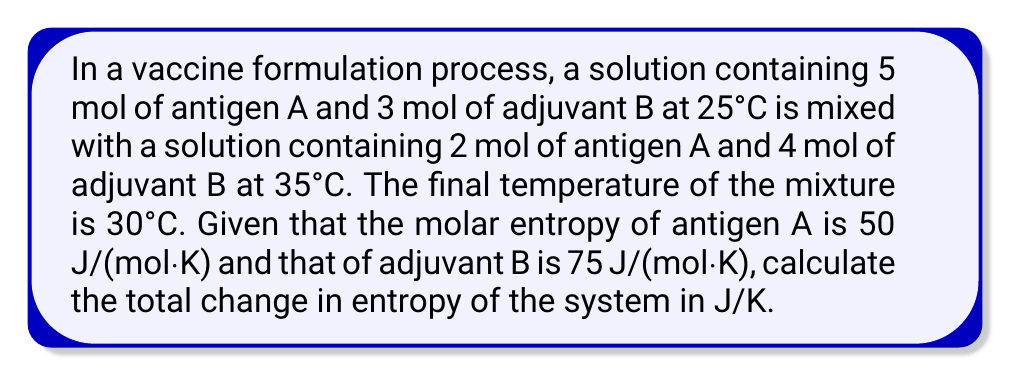Teach me how to tackle this problem. To solve this problem, we need to calculate the entropy change due to mixing and the entropy change due to temperature change.

Step 1: Calculate the initial entropy of each solution
Solution 1 (25°C):
$S_1 = 5 \cdot 50 + 3 \cdot 75 = 475$ J/K

Solution 2 (35°C):
$S_2 = 2 \cdot 50 + 4 \cdot 75 = 400$ J/K

Step 2: Calculate the final entropy of the mixture at 30°C
Total moles of A: $5 + 2 = 7$ mol
Total moles of B: $3 + 4 = 7$ mol
$S_f = 7 \cdot 50 + 7 \cdot 75 = 875$ J/K

Step 3: Calculate the entropy change due to mixing
$\Delta S_{mix} = S_f - (S_1 + S_2) = 875 - (475 + 400) = 0$ J/K

Step 4: Calculate the entropy change due to temperature change
For solution 1 (cooling from 25°C to 30°C):
$\Delta S_1 = (5 \cdot 50 + 3 \cdot 75) \cdot \ln(\frac{303}{298}) = 475 \cdot 0.0166 = 7.885$ J/K

For solution 2 (cooling from 35°C to 30°C):
$\Delta S_2 = (2 \cdot 50 + 4 \cdot 75) \cdot \ln(\frac{303}{308}) = 400 \cdot (-0.0164) = -6.56$ J/K

Step 5: Calculate the total entropy change
$\Delta S_{total} = \Delta S_{mix} + \Delta S_1 + \Delta S_2 = 0 + 7.885 - 6.56 = 1.325$ J/K
Answer: 1.325 J/K 